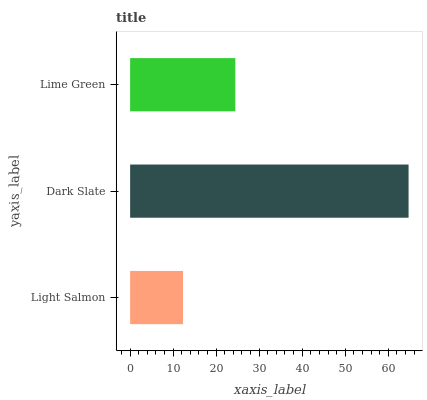Is Light Salmon the minimum?
Answer yes or no. Yes. Is Dark Slate the maximum?
Answer yes or no. Yes. Is Lime Green the minimum?
Answer yes or no. No. Is Lime Green the maximum?
Answer yes or no. No. Is Dark Slate greater than Lime Green?
Answer yes or no. Yes. Is Lime Green less than Dark Slate?
Answer yes or no. Yes. Is Lime Green greater than Dark Slate?
Answer yes or no. No. Is Dark Slate less than Lime Green?
Answer yes or no. No. Is Lime Green the high median?
Answer yes or no. Yes. Is Lime Green the low median?
Answer yes or no. Yes. Is Light Salmon the high median?
Answer yes or no. No. Is Light Salmon the low median?
Answer yes or no. No. 